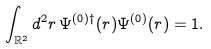<formula> <loc_0><loc_0><loc_500><loc_500>\int _ { \mathbb { R } ^ { 2 } } d ^ { 2 } r \, \Psi ^ { ( 0 ) \dag } ( r ) \Psi ^ { ( 0 ) } ( r ) = 1 .</formula> 